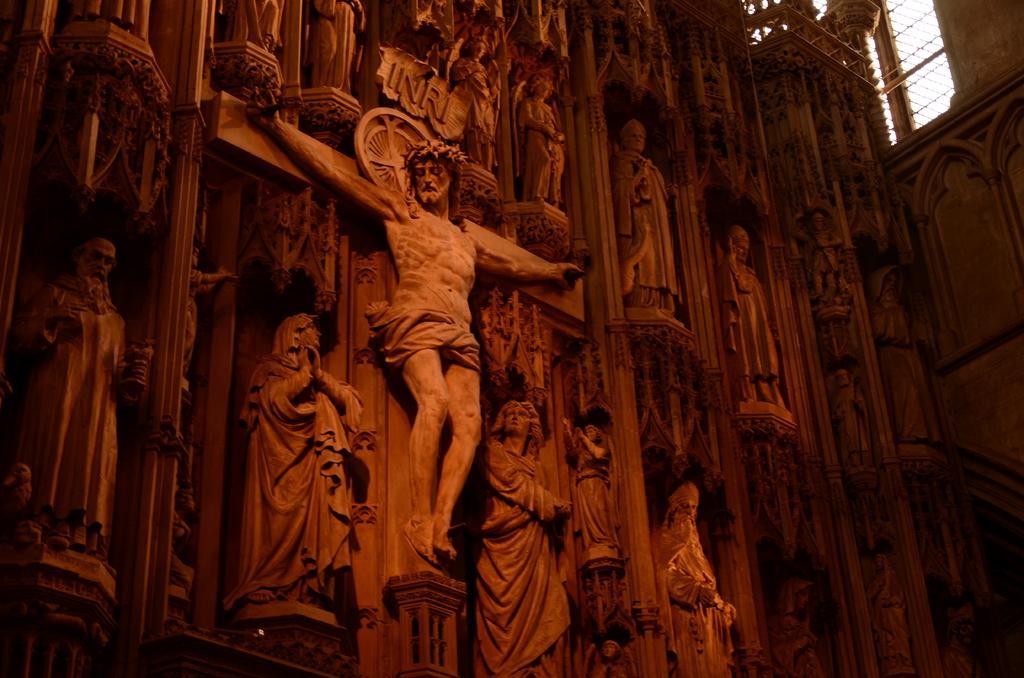Please provide a concise description of this image. In this picture I can see a number of statues on the wall. 